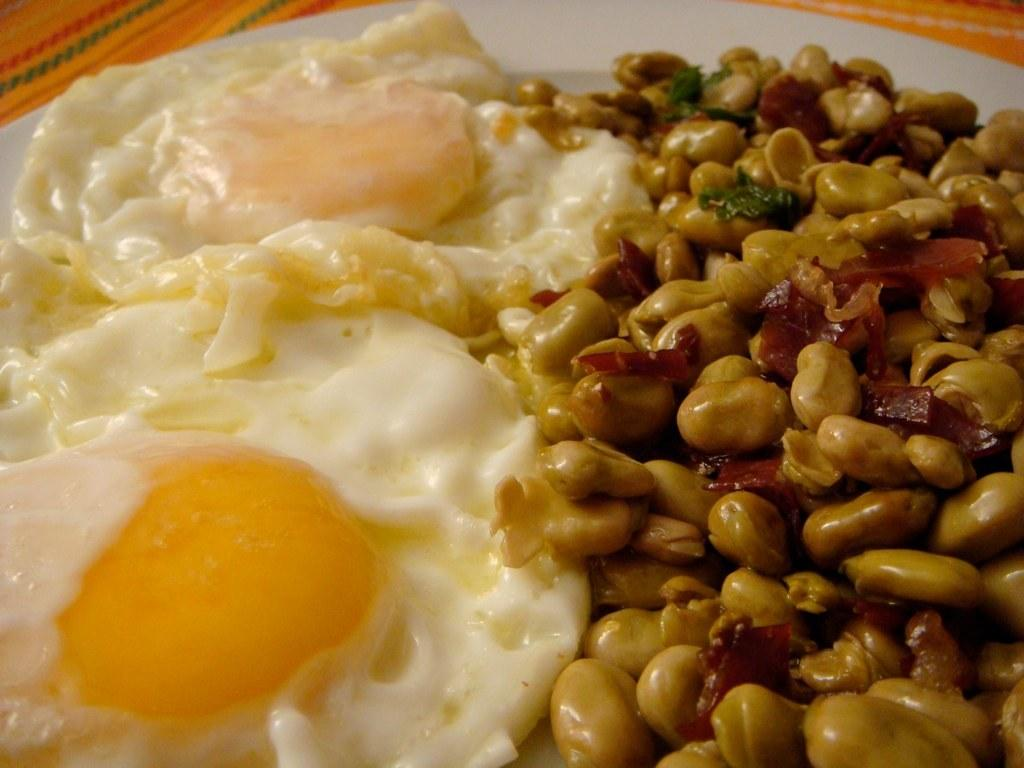What type of dish is being used to serve the food in the image? There is a white plate being used to serve the food in the image. Can you describe the food items on the plate? Unfortunately, the facts provided do not specify the type of food items on the plate. Is there any color or pattern visible on the cloth at the bottom of the image? The facts provided only mention a yellow color cloth, but no specific pattern is mentioned. What type of help is being offered at the meeting in the image? There is no mention of a meeting or any type of help being offered in the image. The image only features a white plate with food items and a yellow color cloth. 